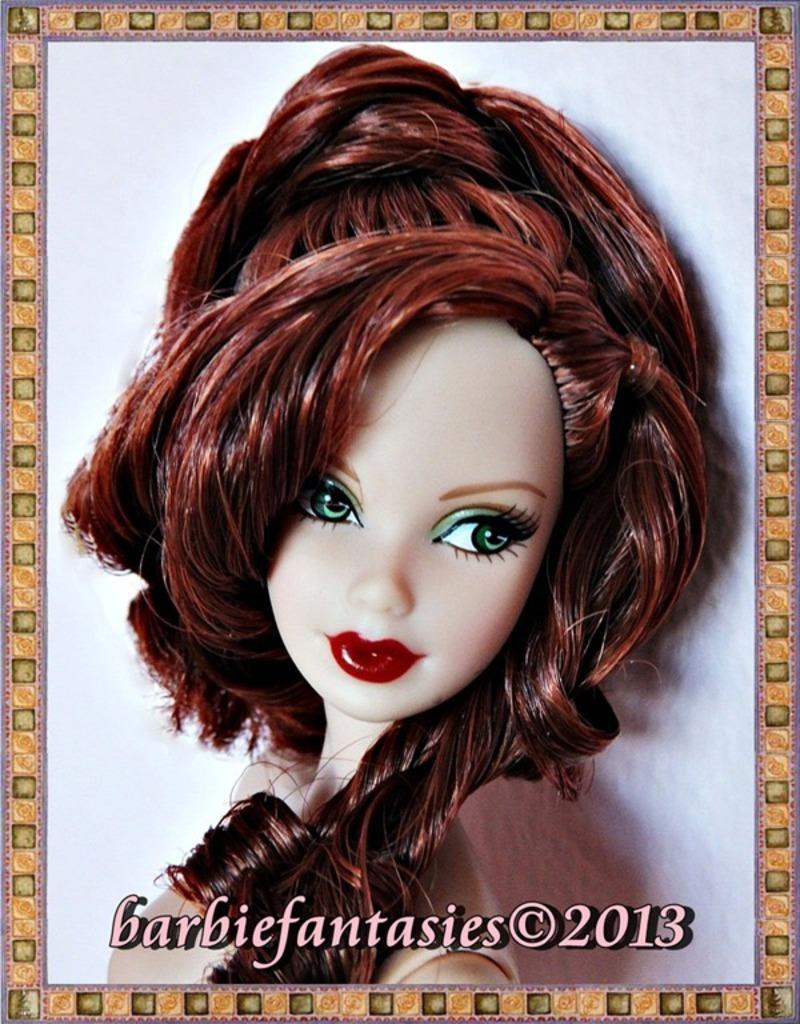What type of doll is in the image? There is a Barbie doll in the image. What color are the Barbie doll's eyes? The Barbie doll has green eyes. What color is the Barbie doll's hair? The Barbie doll has brown hair. What color is the frame around the Barbie doll? The Barbie doll has a yellow frame. What color is the background of the image? The background of the image is white. How many babies are present in the image? There are no babies present in the image; it features a Barbie doll. What type of range can be seen in the image? There is no range present in the image. 